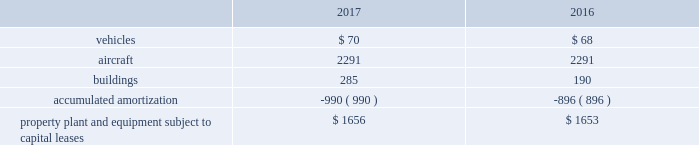United parcel service , inc .
And subsidiaries notes to consolidated financial statements floating-rate senior notes the floating-rate senior notes with principal amounts totaling $ 1.043 billion , bear interest at either one or three-month libor , less a spread ranging from 30 to 45 basis points .
The average interest rate for 2017 and 2016 was 0.74% ( 0.74 % ) and 0.21% ( 0.21 % ) , respectively .
These notes are callable at various times after 30 years at a stated percentage of par value , and putable by the note holders at various times after one year at a stated percentage of par value .
The notes have maturities ranging from 2049 through 2067 .
We classified the floating-rate senior notes that are putable by the note holder as a long-term liability , due to our intent and ability to refinance the debt if the put option is exercised by the note holder .
In march and november 2017 , we issued floating-rate senior notes in the principal amounts of $ 147 and $ 64 million , respectively , which are included in the $ 1.043 billion floating-rate senior notes described above .
These notes will bear interest at three-month libor less 30 and 35 basis points , respectively and mature in 2067 .
The remaining three floating-rate senior notes in the principal amounts of $ 350 , $ 400 and $ 500 million , bear interest at three-month libor , plus a spread ranging from 15 to 45 basis points .
The average interest rate for 2017 and 2016 was 0.50% ( 0.50 % ) and 0.0% ( 0.0 % ) , respectively .
These notes are not callable .
The notes have maturities ranging from 2021 through 2023 .
We classified the floating-rate senior notes that are putable by the note holder as a long-term liability , due to our intent and ability to refinance the debt if the put option is exercised by the note holder .
Capital lease obligations we have certain property , plant and equipment subject to capital leases .
Some of the obligations associated with these capital leases have been legally defeased .
The recorded value of our property , plant and equipment subject to capital leases is as follows as of december 31 ( in millions ) : .
These capital lease obligations have principal payments due at various dates from 2018 through 3005 .
Facility notes and bonds we have entered into agreements with certain municipalities to finance the construction of , or improvements to , facilities that support our u.s .
Domestic package and supply chain & freight operations in the united states .
These facilities are located around airport properties in louisville , kentucky ; dallas , texas ; and philadelphia , pennsylvania .
Under these arrangements , we enter into a lease or loan agreement that covers the debt service obligations on the bonds issued by the municipalities , as follows : 2022 bonds with a principal balance of $ 149 million issued by the louisville regional airport authority associated with our worldport facility in louisville , kentucky .
The bonds , which are due in january 2029 , bear interest at a variable rate , and the average interest rates for 2017 and 2016 were 0.83% ( 0.83 % ) and 0.37% ( 0.37 % ) , respectively .
2022 bonds with a principal balance of $ 42 million and due in november 2036 issued by the louisville regional airport authority associated with our air freight facility in louisville , kentucky .
The bonds bear interest at a variable rate , and the average interest rates for 2017 and 2016 were 0.80% ( 0.80 % ) and 0.36% ( 0.36 % ) , respectively .
2022 bonds with a principal balance of $ 29 million issued by the dallas / fort worth international airport facility improvement corporation associated with our dallas , texas airport facilities .
The bonds are due in may 2032 and bear interest at a variable rate , however the variable cash flows on the obligation have been swapped to a fixed 5.11% ( 5.11 % ) .
2022 in september 2015 , we entered into an agreement with the delaware county , pennsylvania industrial development authority , associated with our philadelphia , pennsylvania airport facilities , for bonds issued with a principal balance of $ 100 million .
These bonds , which are due september 2045 , bear interest at a variable rate .
The average interest rate for 2017 and 2016 was 0.78% ( 0.78 % ) and 0.40% ( 0.40 % ) , respectively. .
What was the change in millions of vehicles from 2016 to 2017? 
Computations: (70 - 68)
Answer: 2.0. United parcel service , inc .
And subsidiaries notes to consolidated financial statements floating-rate senior notes the floating-rate senior notes with principal amounts totaling $ 1.043 billion , bear interest at either one or three-month libor , less a spread ranging from 30 to 45 basis points .
The average interest rate for 2017 and 2016 was 0.74% ( 0.74 % ) and 0.21% ( 0.21 % ) , respectively .
These notes are callable at various times after 30 years at a stated percentage of par value , and putable by the note holders at various times after one year at a stated percentage of par value .
The notes have maturities ranging from 2049 through 2067 .
We classified the floating-rate senior notes that are putable by the note holder as a long-term liability , due to our intent and ability to refinance the debt if the put option is exercised by the note holder .
In march and november 2017 , we issued floating-rate senior notes in the principal amounts of $ 147 and $ 64 million , respectively , which are included in the $ 1.043 billion floating-rate senior notes described above .
These notes will bear interest at three-month libor less 30 and 35 basis points , respectively and mature in 2067 .
The remaining three floating-rate senior notes in the principal amounts of $ 350 , $ 400 and $ 500 million , bear interest at three-month libor , plus a spread ranging from 15 to 45 basis points .
The average interest rate for 2017 and 2016 was 0.50% ( 0.50 % ) and 0.0% ( 0.0 % ) , respectively .
These notes are not callable .
The notes have maturities ranging from 2021 through 2023 .
We classified the floating-rate senior notes that are putable by the note holder as a long-term liability , due to our intent and ability to refinance the debt if the put option is exercised by the note holder .
Capital lease obligations we have certain property , plant and equipment subject to capital leases .
Some of the obligations associated with these capital leases have been legally defeased .
The recorded value of our property , plant and equipment subject to capital leases is as follows as of december 31 ( in millions ) : .
These capital lease obligations have principal payments due at various dates from 2018 through 3005 .
Facility notes and bonds we have entered into agreements with certain municipalities to finance the construction of , or improvements to , facilities that support our u.s .
Domestic package and supply chain & freight operations in the united states .
These facilities are located around airport properties in louisville , kentucky ; dallas , texas ; and philadelphia , pennsylvania .
Under these arrangements , we enter into a lease or loan agreement that covers the debt service obligations on the bonds issued by the municipalities , as follows : 2022 bonds with a principal balance of $ 149 million issued by the louisville regional airport authority associated with our worldport facility in louisville , kentucky .
The bonds , which are due in january 2029 , bear interest at a variable rate , and the average interest rates for 2017 and 2016 were 0.83% ( 0.83 % ) and 0.37% ( 0.37 % ) , respectively .
2022 bonds with a principal balance of $ 42 million and due in november 2036 issued by the louisville regional airport authority associated with our air freight facility in louisville , kentucky .
The bonds bear interest at a variable rate , and the average interest rates for 2017 and 2016 were 0.80% ( 0.80 % ) and 0.36% ( 0.36 % ) , respectively .
2022 bonds with a principal balance of $ 29 million issued by the dallas / fort worth international airport facility improvement corporation associated with our dallas , texas airport facilities .
The bonds are due in may 2032 and bear interest at a variable rate , however the variable cash flows on the obligation have been swapped to a fixed 5.11% ( 5.11 % ) .
2022 in september 2015 , we entered into an agreement with the delaware county , pennsylvania industrial development authority , associated with our philadelphia , pennsylvania airport facilities , for bonds issued with a principal balance of $ 100 million .
These bonds , which are due september 2045 , bear interest at a variable rate .
The average interest rate for 2017 and 2016 was 0.78% ( 0.78 % ) and 0.40% ( 0.40 % ) , respectively. .
What was the percentage change in building under capital lease from 2016 to 2017? 
Computations: ((285 - 190) / 190)
Answer: 0.5. 